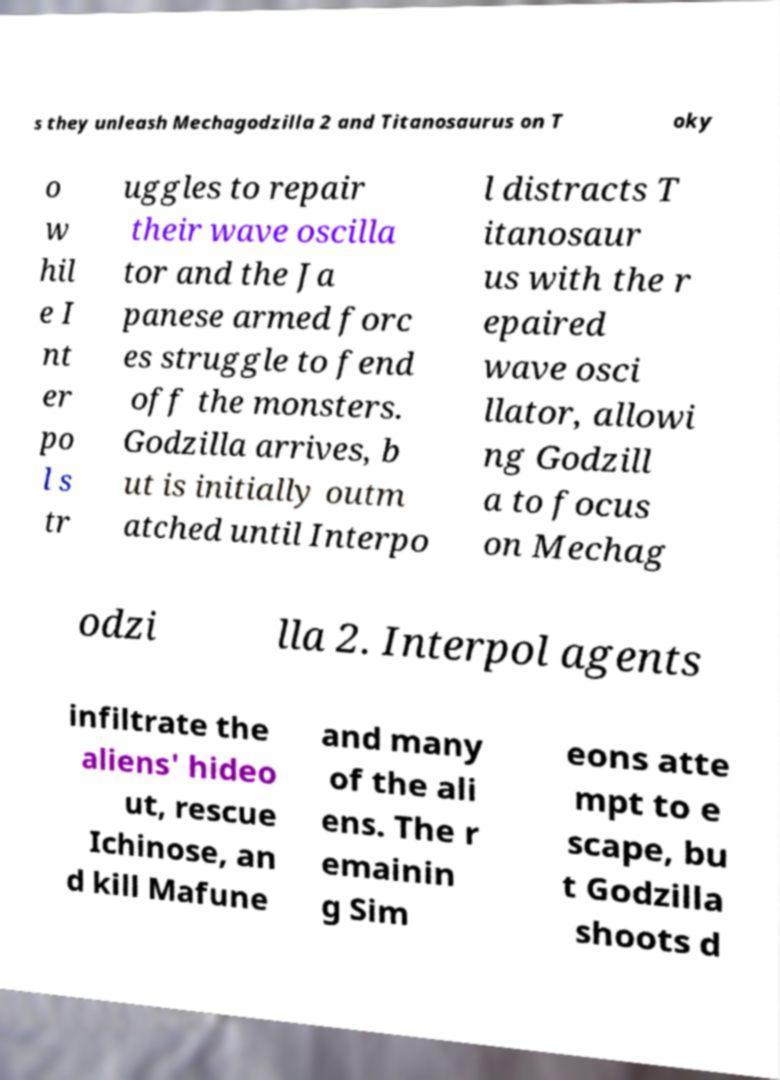What messages or text are displayed in this image? I need them in a readable, typed format. s they unleash Mechagodzilla 2 and Titanosaurus on T oky o w hil e I nt er po l s tr uggles to repair their wave oscilla tor and the Ja panese armed forc es struggle to fend off the monsters. Godzilla arrives, b ut is initially outm atched until Interpo l distracts T itanosaur us with the r epaired wave osci llator, allowi ng Godzill a to focus on Mechag odzi lla 2. Interpol agents infiltrate the aliens' hideo ut, rescue Ichinose, an d kill Mafune and many of the ali ens. The r emainin g Sim eons atte mpt to e scape, bu t Godzilla shoots d 